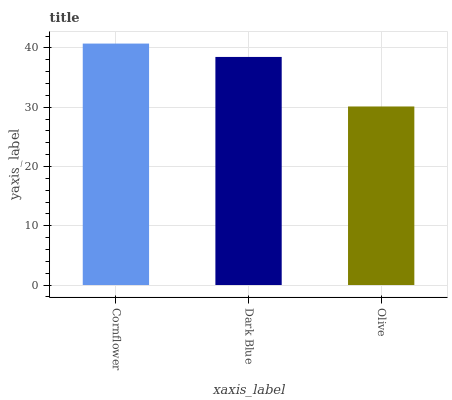Is Olive the minimum?
Answer yes or no. Yes. Is Cornflower the maximum?
Answer yes or no. Yes. Is Dark Blue the minimum?
Answer yes or no. No. Is Dark Blue the maximum?
Answer yes or no. No. Is Cornflower greater than Dark Blue?
Answer yes or no. Yes. Is Dark Blue less than Cornflower?
Answer yes or no. Yes. Is Dark Blue greater than Cornflower?
Answer yes or no. No. Is Cornflower less than Dark Blue?
Answer yes or no. No. Is Dark Blue the high median?
Answer yes or no. Yes. Is Dark Blue the low median?
Answer yes or no. Yes. Is Cornflower the high median?
Answer yes or no. No. Is Olive the low median?
Answer yes or no. No. 